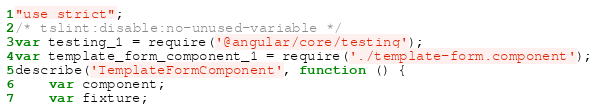<code> <loc_0><loc_0><loc_500><loc_500><_JavaScript_>"use strict";
/* tslint:disable:no-unused-variable */
var testing_1 = require('@angular/core/testing');
var template_form_component_1 = require('./template-form.component');
describe('TemplateFormComponent', function () {
    var component;
    var fixture;</code> 